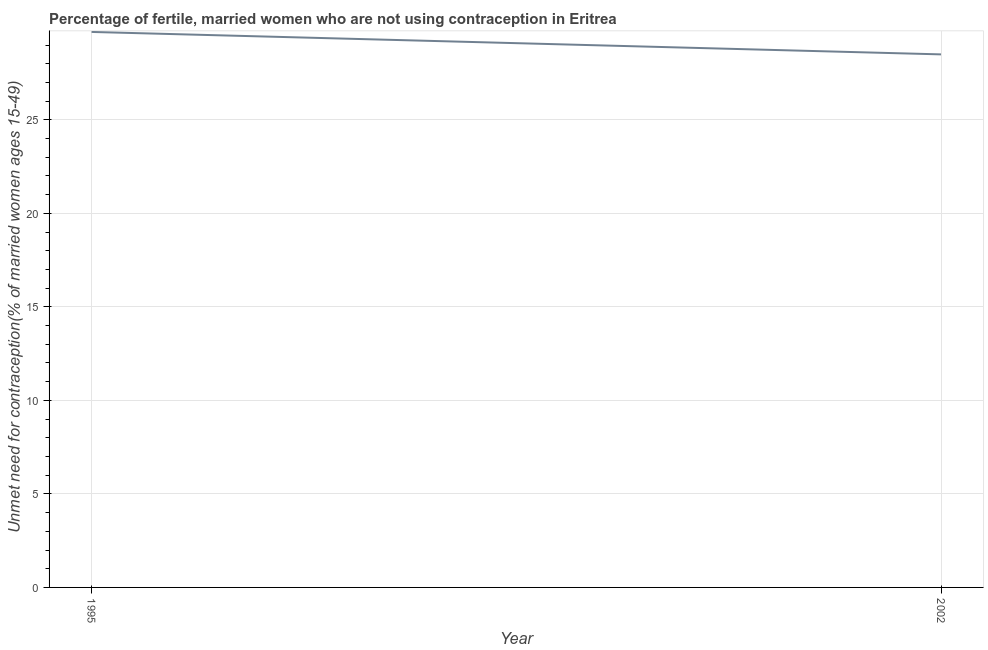What is the number of married women who are not using contraception in 2002?
Your response must be concise. 28.5. Across all years, what is the maximum number of married women who are not using contraception?
Offer a terse response. 29.7. Across all years, what is the minimum number of married women who are not using contraception?
Provide a succinct answer. 28.5. In which year was the number of married women who are not using contraception maximum?
Your response must be concise. 1995. In which year was the number of married women who are not using contraception minimum?
Offer a terse response. 2002. What is the sum of the number of married women who are not using contraception?
Keep it short and to the point. 58.2. What is the difference between the number of married women who are not using contraception in 1995 and 2002?
Your response must be concise. 1.2. What is the average number of married women who are not using contraception per year?
Offer a very short reply. 29.1. What is the median number of married women who are not using contraception?
Your answer should be compact. 29.1. Do a majority of the years between 1995 and 2002 (inclusive) have number of married women who are not using contraception greater than 10 %?
Make the answer very short. Yes. What is the ratio of the number of married women who are not using contraception in 1995 to that in 2002?
Give a very brief answer. 1.04. How many lines are there?
Give a very brief answer. 1. How many years are there in the graph?
Provide a short and direct response. 2. Does the graph contain grids?
Provide a succinct answer. Yes. What is the title of the graph?
Keep it short and to the point. Percentage of fertile, married women who are not using contraception in Eritrea. What is the label or title of the X-axis?
Your answer should be very brief. Year. What is the label or title of the Y-axis?
Provide a succinct answer.  Unmet need for contraception(% of married women ages 15-49). What is the  Unmet need for contraception(% of married women ages 15-49) in 1995?
Give a very brief answer. 29.7. What is the  Unmet need for contraception(% of married women ages 15-49) in 2002?
Your answer should be compact. 28.5. What is the ratio of the  Unmet need for contraception(% of married women ages 15-49) in 1995 to that in 2002?
Offer a very short reply. 1.04. 